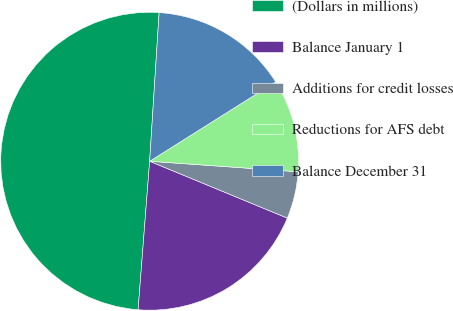<chart> <loc_0><loc_0><loc_500><loc_500><pie_chart><fcel>(Dollars in millions)<fcel>Balance January 1<fcel>Additions for credit losses<fcel>Reductions for AFS debt<fcel>Balance December 31<nl><fcel>49.78%<fcel>20.0%<fcel>5.11%<fcel>10.07%<fcel>15.04%<nl></chart> 